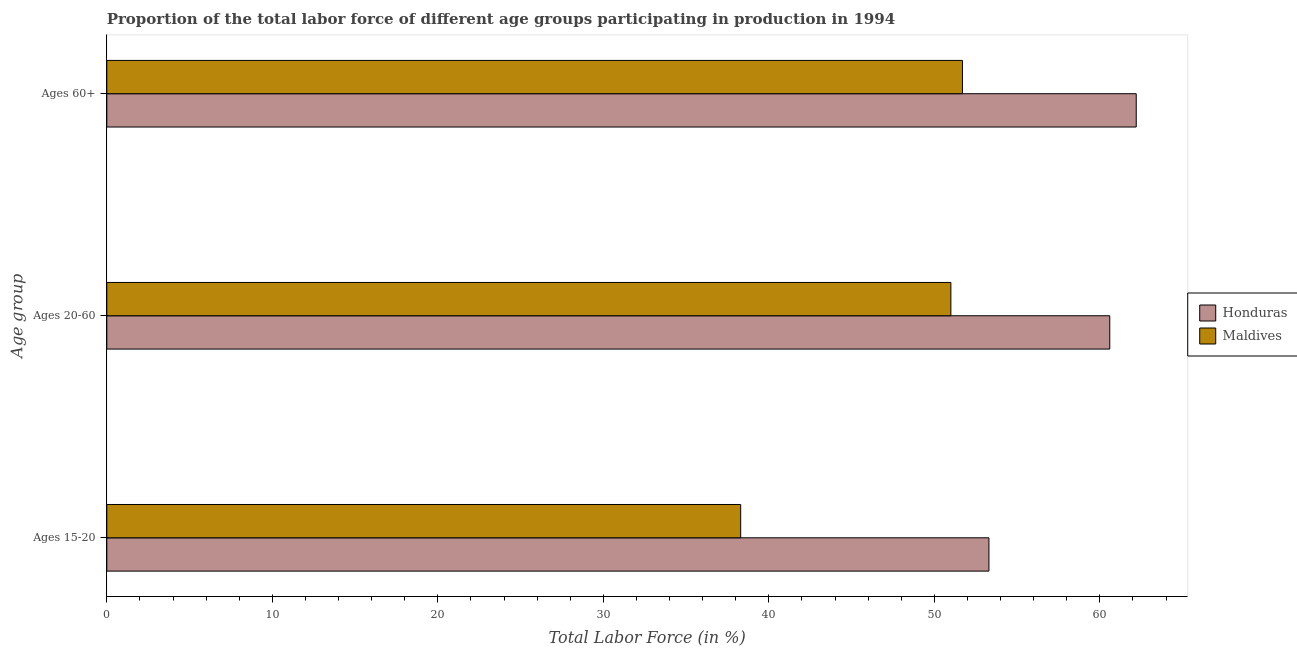How many groups of bars are there?
Offer a very short reply. 3. How many bars are there on the 3rd tick from the top?
Offer a terse response. 2. What is the label of the 2nd group of bars from the top?
Your answer should be very brief. Ages 20-60. What is the percentage of labor force within the age group 15-20 in Maldives?
Offer a terse response. 38.3. Across all countries, what is the maximum percentage of labor force above age 60?
Make the answer very short. 62.2. Across all countries, what is the minimum percentage of labor force within the age group 15-20?
Your response must be concise. 38.3. In which country was the percentage of labor force within the age group 15-20 maximum?
Keep it short and to the point. Honduras. In which country was the percentage of labor force above age 60 minimum?
Ensure brevity in your answer.  Maldives. What is the total percentage of labor force within the age group 15-20 in the graph?
Provide a succinct answer. 91.6. What is the difference between the percentage of labor force within the age group 20-60 in Honduras and that in Maldives?
Your answer should be compact. 9.6. What is the difference between the percentage of labor force within the age group 20-60 in Honduras and the percentage of labor force above age 60 in Maldives?
Keep it short and to the point. 8.9. What is the average percentage of labor force above age 60 per country?
Provide a succinct answer. 56.95. What is the difference between the percentage of labor force within the age group 15-20 and percentage of labor force above age 60 in Honduras?
Your answer should be compact. -8.9. In how many countries, is the percentage of labor force above age 60 greater than 46 %?
Your response must be concise. 2. What is the ratio of the percentage of labor force within the age group 15-20 in Honduras to that in Maldives?
Give a very brief answer. 1.39. Is the difference between the percentage of labor force within the age group 20-60 in Maldives and Honduras greater than the difference between the percentage of labor force within the age group 15-20 in Maldives and Honduras?
Ensure brevity in your answer.  Yes. What is the difference between the highest and the second highest percentage of labor force within the age group 15-20?
Ensure brevity in your answer.  15. What is the difference between the highest and the lowest percentage of labor force within the age group 20-60?
Your response must be concise. 9.6. In how many countries, is the percentage of labor force within the age group 15-20 greater than the average percentage of labor force within the age group 15-20 taken over all countries?
Make the answer very short. 1. Is the sum of the percentage of labor force within the age group 20-60 in Maldives and Honduras greater than the maximum percentage of labor force above age 60 across all countries?
Your answer should be very brief. Yes. What does the 1st bar from the top in Ages 15-20 represents?
Offer a terse response. Maldives. What does the 1st bar from the bottom in Ages 60+ represents?
Your response must be concise. Honduras. Is it the case that in every country, the sum of the percentage of labor force within the age group 15-20 and percentage of labor force within the age group 20-60 is greater than the percentage of labor force above age 60?
Offer a terse response. Yes. How many countries are there in the graph?
Make the answer very short. 2. What is the difference between two consecutive major ticks on the X-axis?
Make the answer very short. 10. Are the values on the major ticks of X-axis written in scientific E-notation?
Offer a very short reply. No. How are the legend labels stacked?
Provide a succinct answer. Vertical. What is the title of the graph?
Offer a terse response. Proportion of the total labor force of different age groups participating in production in 1994. Does "Singapore" appear as one of the legend labels in the graph?
Give a very brief answer. No. What is the label or title of the Y-axis?
Keep it short and to the point. Age group. What is the Total Labor Force (in %) in Honduras in Ages 15-20?
Your answer should be very brief. 53.3. What is the Total Labor Force (in %) of Maldives in Ages 15-20?
Offer a very short reply. 38.3. What is the Total Labor Force (in %) of Honduras in Ages 20-60?
Provide a succinct answer. 60.6. What is the Total Labor Force (in %) in Maldives in Ages 20-60?
Your response must be concise. 51. What is the Total Labor Force (in %) in Honduras in Ages 60+?
Provide a short and direct response. 62.2. What is the Total Labor Force (in %) in Maldives in Ages 60+?
Offer a very short reply. 51.7. Across all Age group, what is the maximum Total Labor Force (in %) of Honduras?
Keep it short and to the point. 62.2. Across all Age group, what is the maximum Total Labor Force (in %) of Maldives?
Provide a short and direct response. 51.7. Across all Age group, what is the minimum Total Labor Force (in %) in Honduras?
Your response must be concise. 53.3. Across all Age group, what is the minimum Total Labor Force (in %) in Maldives?
Ensure brevity in your answer.  38.3. What is the total Total Labor Force (in %) in Honduras in the graph?
Your answer should be compact. 176.1. What is the total Total Labor Force (in %) of Maldives in the graph?
Provide a succinct answer. 141. What is the difference between the Total Labor Force (in %) in Honduras in Ages 15-20 and that in Ages 60+?
Your answer should be compact. -8.9. What is the difference between the Total Labor Force (in %) of Honduras in Ages 20-60 and that in Ages 60+?
Your response must be concise. -1.6. What is the difference between the Total Labor Force (in %) in Honduras in Ages 15-20 and the Total Labor Force (in %) in Maldives in Ages 20-60?
Your answer should be very brief. 2.3. What is the difference between the Total Labor Force (in %) in Honduras in Ages 15-20 and the Total Labor Force (in %) in Maldives in Ages 60+?
Keep it short and to the point. 1.6. What is the difference between the Total Labor Force (in %) of Honduras in Ages 20-60 and the Total Labor Force (in %) of Maldives in Ages 60+?
Your response must be concise. 8.9. What is the average Total Labor Force (in %) of Honduras per Age group?
Provide a short and direct response. 58.7. What is the ratio of the Total Labor Force (in %) in Honduras in Ages 15-20 to that in Ages 20-60?
Offer a very short reply. 0.88. What is the ratio of the Total Labor Force (in %) in Maldives in Ages 15-20 to that in Ages 20-60?
Your response must be concise. 0.75. What is the ratio of the Total Labor Force (in %) in Honduras in Ages 15-20 to that in Ages 60+?
Provide a short and direct response. 0.86. What is the ratio of the Total Labor Force (in %) of Maldives in Ages 15-20 to that in Ages 60+?
Provide a short and direct response. 0.74. What is the ratio of the Total Labor Force (in %) in Honduras in Ages 20-60 to that in Ages 60+?
Your response must be concise. 0.97. What is the ratio of the Total Labor Force (in %) in Maldives in Ages 20-60 to that in Ages 60+?
Your response must be concise. 0.99. What is the difference between the highest and the second highest Total Labor Force (in %) of Maldives?
Make the answer very short. 0.7. What is the difference between the highest and the lowest Total Labor Force (in %) of Honduras?
Offer a terse response. 8.9. 